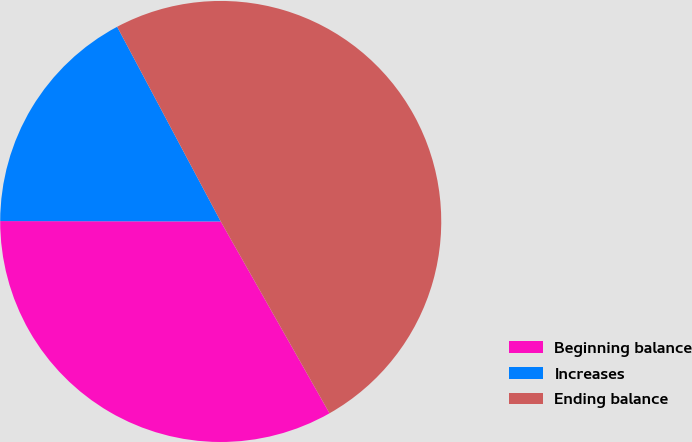<chart> <loc_0><loc_0><loc_500><loc_500><pie_chart><fcel>Beginning balance<fcel>Increases<fcel>Ending balance<nl><fcel>33.24%<fcel>17.19%<fcel>49.57%<nl></chart> 